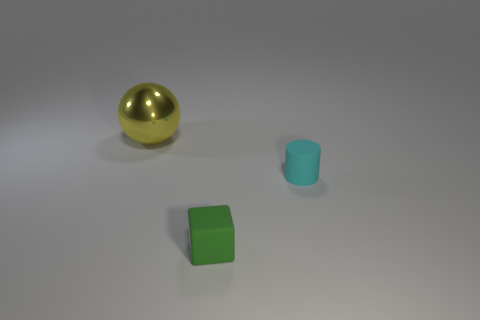Add 1 yellow rubber balls. How many objects exist? 4 Subtract all cylinders. How many objects are left? 2 Add 3 tiny red matte cubes. How many tiny red matte cubes exist? 3 Subtract 0 brown cubes. How many objects are left? 3 Subtract all tiny purple balls. Subtract all tiny green blocks. How many objects are left? 2 Add 1 matte things. How many matte things are left? 3 